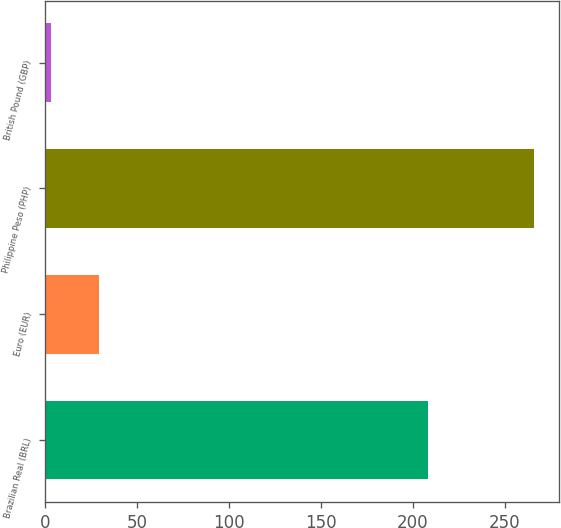<chart> <loc_0><loc_0><loc_500><loc_500><bar_chart><fcel>Brazilian Real (BRL)<fcel>Euro (EUR)<fcel>Philippine Peso (PHP)<fcel>British Pound (GBP)<nl><fcel>208<fcel>29.3<fcel>266<fcel>3<nl></chart> 